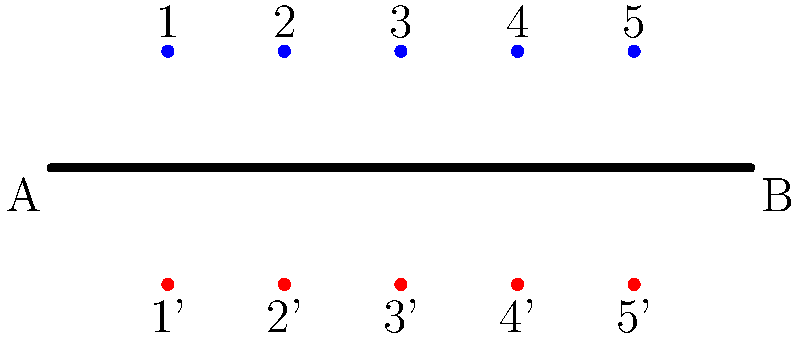In your latest runway shoot for Eleni Epstein's fashion line, you're working with a symmetrical stage layout as shown above. The runway extends from point A to B, with 5 VIP seats on each side (blue dots represent seats 1-5, red dots represent seats 1'-5'). How many elements are in the dihedral group $D_5$ that describes the symmetries of this seating arrangement, and what does each element represent in terms of the physical layout? To answer this question, let's break down the symmetries of the runway seating arrangement:

1. The dihedral group $D_5$ describes the symmetries of a regular pentagon, which corresponds to the 5 pairs of seats in our layout.

2. The elements of $D_5$ consist of:
   a) Rotations: There are 5 rotations (including the identity rotation):
      - Identity (no change)
      - Rotate by 72° (1 step)
      - Rotate by 144° (2 steps)
      - Rotate by 216° (3 steps)
      - Rotate by 288° (4 steps)
   
   b) Reflections: There are 5 reflections:
      - Reflect across the line AB (swap sides)
      - Reflect across the line perpendicular to AB through seat 1/1'
      - Reflect across the line perpendicular to AB through seat 2/2'
      - Reflect across the line perpendicular to AB through seat 3/3'
      - Reflect across the line perpendicular to AB through seat 4/4'

3. The total number of elements in $D_5$ is therefore 5 (rotations) + 5 (reflections) = 10.

4. Physical interpretations:
   - Rotations correspond to shifting all guests along the runway (e.g., 1 to 2, 2 to 3, etc., wrapping around)
   - Reflections across AB swap the sides of the runway
   - Other reflections swap sides and shift positions simultaneously

This group structure ensures that all possible rearrangements of the VIP guests that maintain the symmetry of the layout are accounted for, which is crucial for maintaining the aesthetic balance of Eleni Epstein's runway show.
Answer: 10 elements: 5 rotations (shifting seats) and 5 reflections (swapping sides and/or positions) 